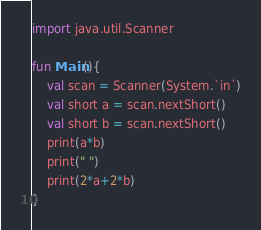Convert code to text. <code><loc_0><loc_0><loc_500><loc_500><_Kotlin_>import java.util.Scanner

fun Main(){
    val scan = Scanner(System.`in`)
    val short a = scan.nextShort()
    val short b = scan.nextShort()
    print(a*b)
    print(" ")
    print(2*a+2*b) 
}
</code> 